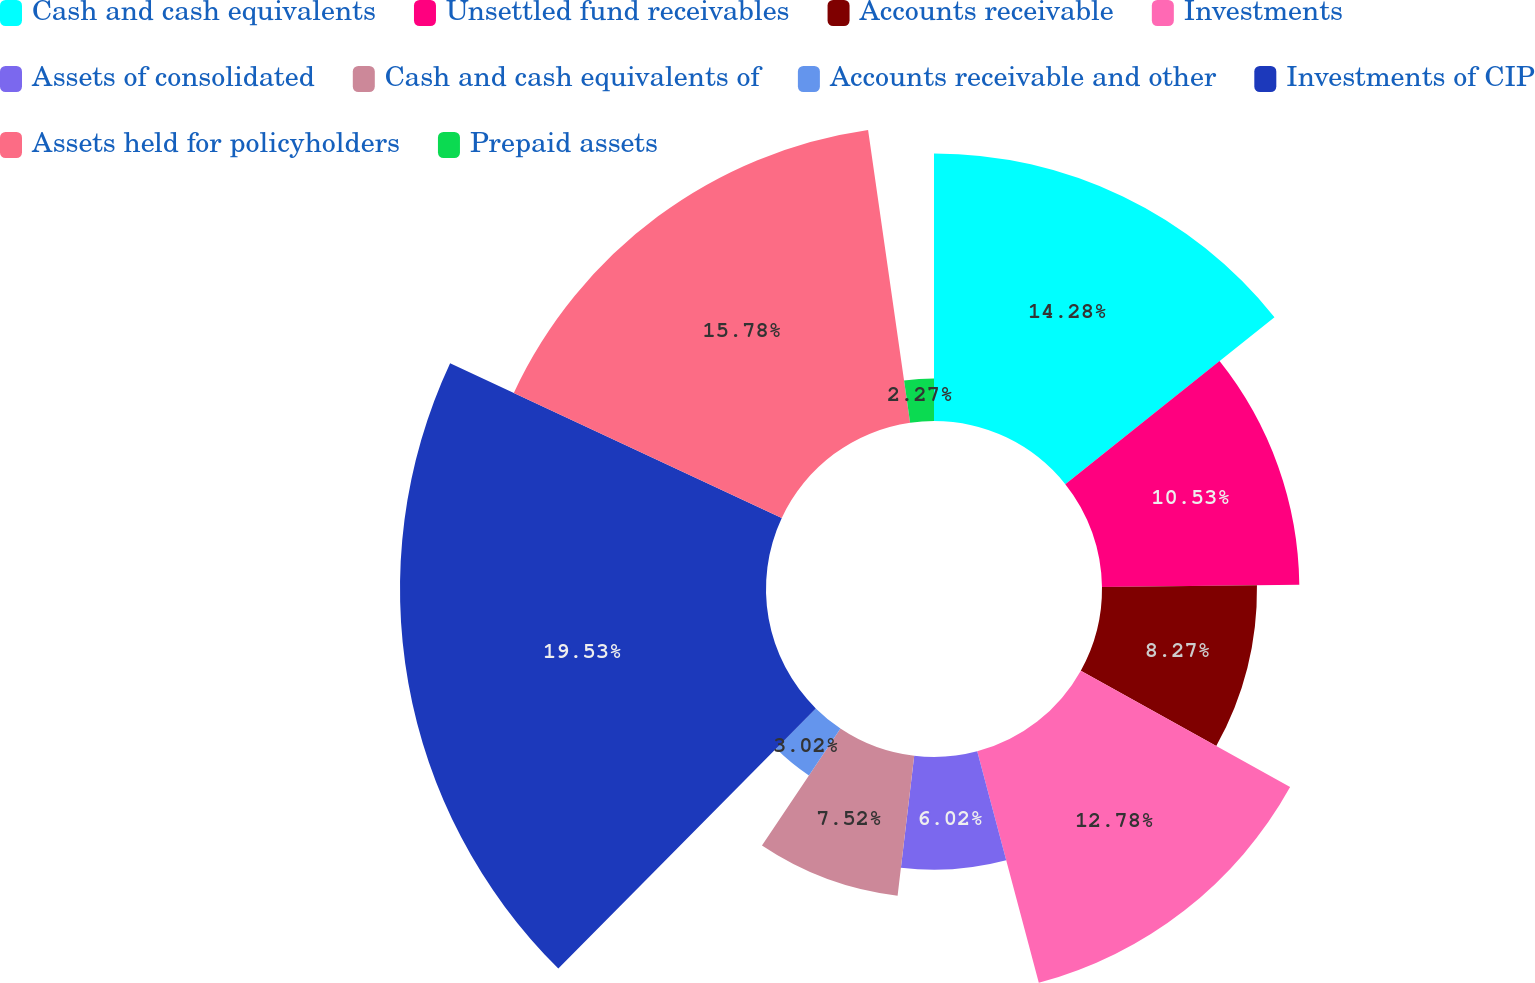Convert chart to OTSL. <chart><loc_0><loc_0><loc_500><loc_500><pie_chart><fcel>Cash and cash equivalents<fcel>Unsettled fund receivables<fcel>Accounts receivable<fcel>Investments<fcel>Assets of consolidated<fcel>Cash and cash equivalents of<fcel>Accounts receivable and other<fcel>Investments of CIP<fcel>Assets held for policyholders<fcel>Prepaid assets<nl><fcel>14.28%<fcel>10.53%<fcel>8.27%<fcel>12.78%<fcel>6.02%<fcel>7.52%<fcel>3.02%<fcel>19.53%<fcel>15.78%<fcel>2.27%<nl></chart> 